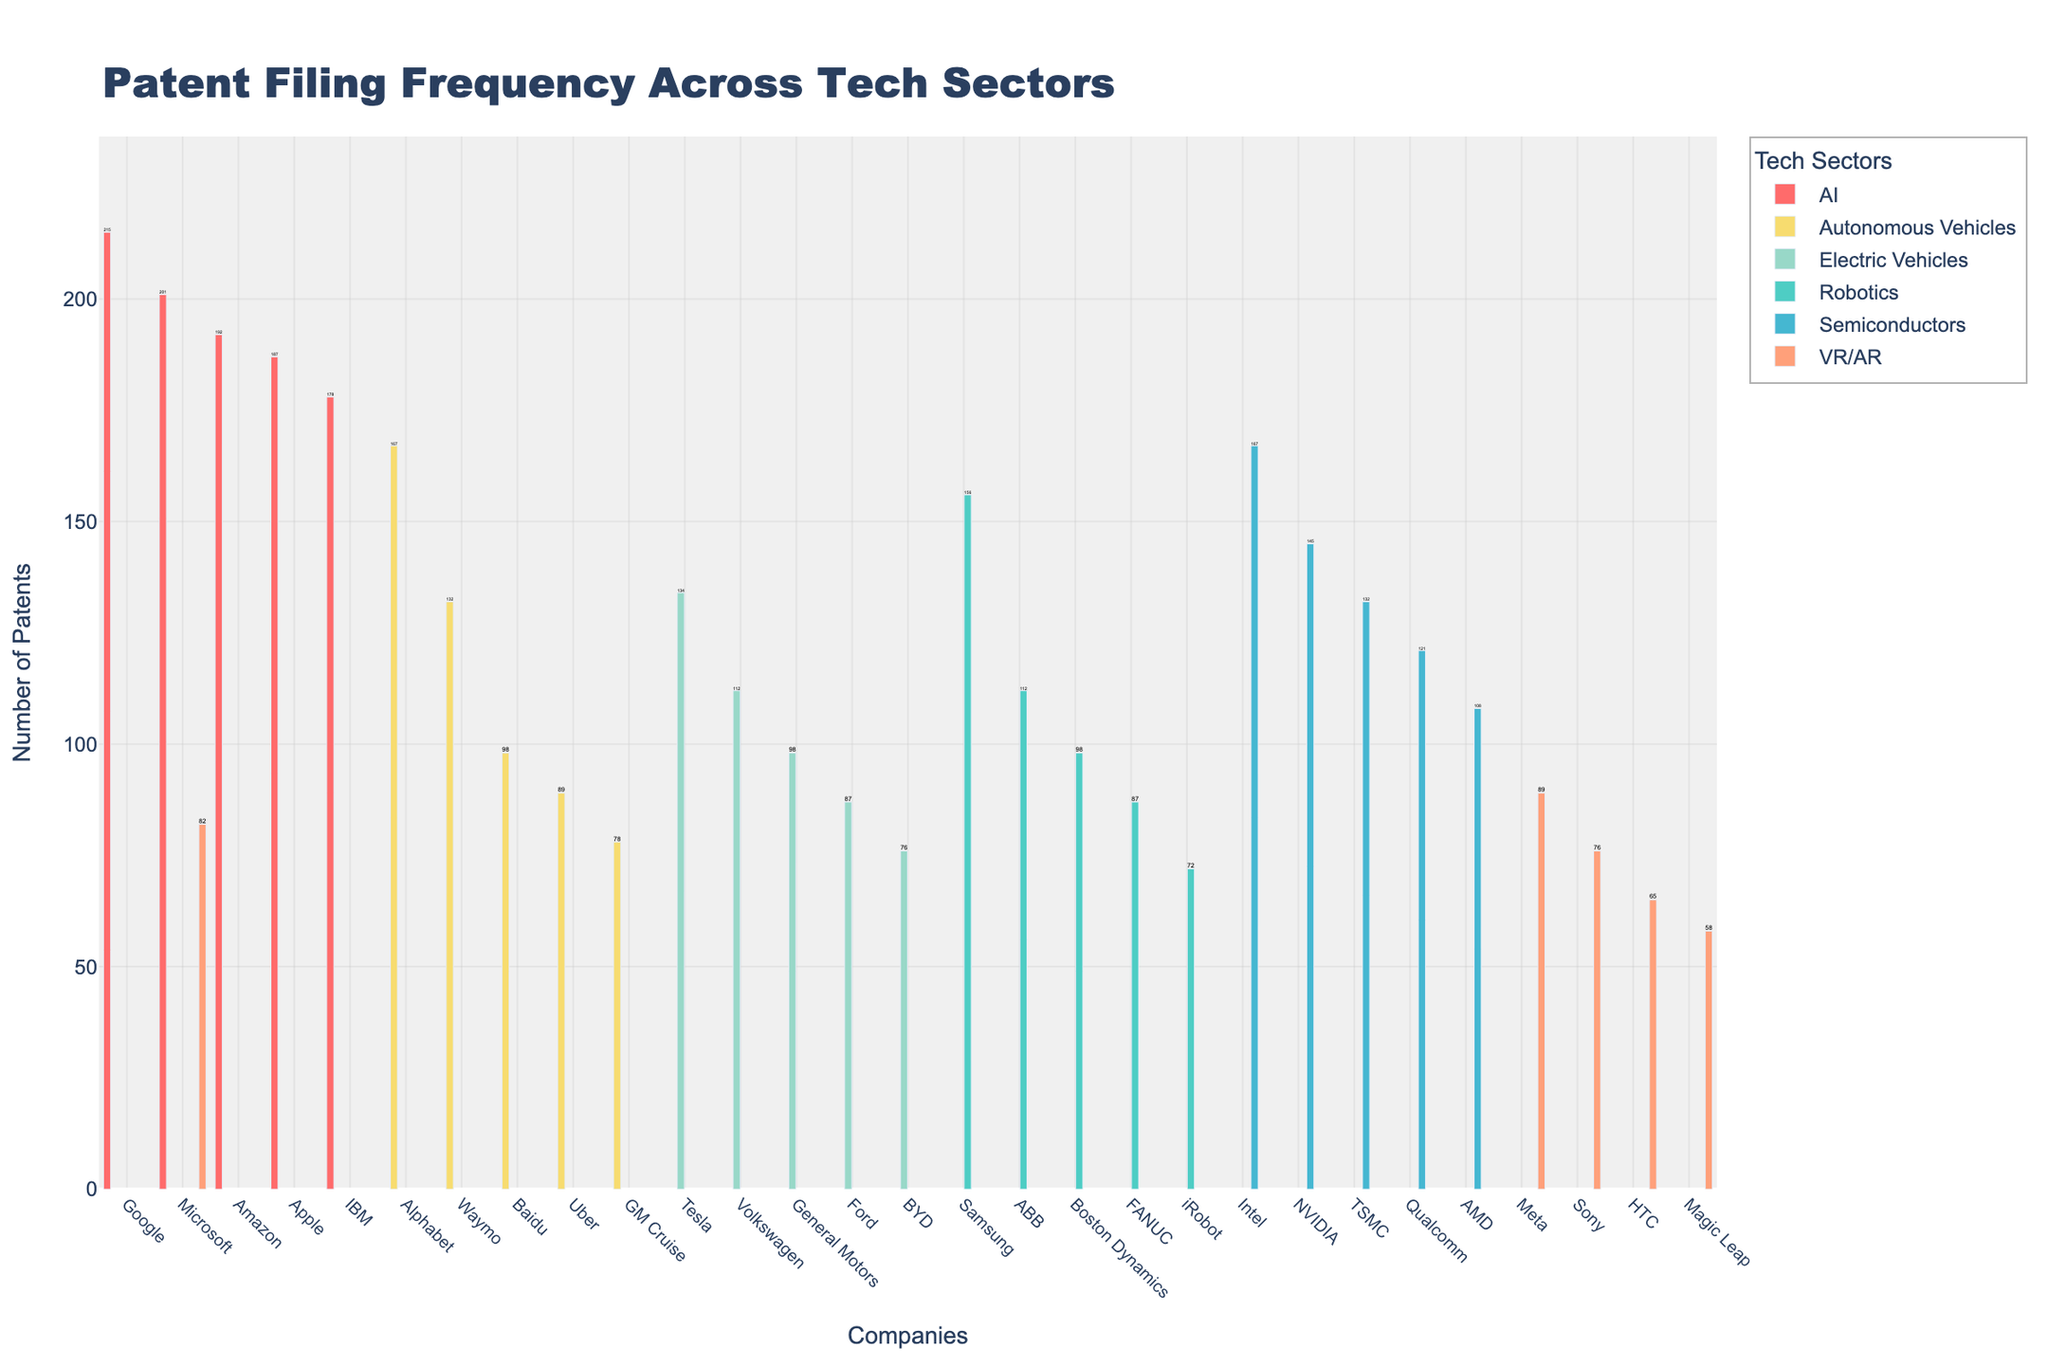What is the total number of patents filed by AI companies? Add the patent counts of companies in the AI sector: Apple (187), Google (215), Microsoft (201), IBM (178), Amazon (192). Their sum is 187 + 215 + 201 + 178 + 192 = 973.
Answer: 973 Which sector has the highest number of patents filed by a single company? Identify the highest patent count filed by a single company across all sectors. Google in the AI sector has the highest with 215 patents.
Answer: AI How many companies in the Electric Vehicles sector have filed patents? Count the number of companies in the Electric Vehicles sector listed in the chart: Tesla, General Motors, Ford, Volkswagen, and BYD. There are 5 companies.
Answer: 5 Which company in the Robotics sector has the least number of patents filed? Identify the company with the lowest patent count in the Robotics sector. iRobot has the least with 72 patents.
Answer: iRobot Compare the patent counts of NVIDIA and Intel in the Semiconductors sector. Which one is higher, and by how much? NVIDIA has 145 patents and Intel has 167 patents. Intel has 167 - 145 = 22 more patents than NVIDIA.
Answer: Intel by 22 How many sectors have at least one company with more than 150 patents filed? Count the sectors where at least one company has more than 150 patents. Sectors fitting this are AI (Google, Microsoft), Semiconductors (Intel), Electric Vehicles (none), Autonomous Vehicles (Alphabet). There are 3 sectors.
Answer: 3 What is the average number of patents filed per company in the VR/AR sector? Calculate the average by summing the patents in VR/AR and dividing by the number of companies: Meta (89), Sony (76), HTC (65), Magic Leap (58), Microsoft (82). Sum is 89 + 76 + 65 + 58 + 82 = 370. Average is 370 / 5 = 74.
Answer: 74 Among the companies listed in the Autonomous Vehicles sector, which one has filed the second most patents? List the patent counts in Autonomous Vehicles: Alphabet (167), Waymo (132), Baidu (98), Uber (89), GM Cruise (78). Waymo with 132 patents is the second highest.
Answer: Waymo What is the total number of patents filed by companies in the Robotics sector? Add the patent counts of companies in the Robotics sector: Samsung (156), Boston Dynamics (98), ABB (112), FANUC (87), iRobot (72). Their sum is 156 + 98 + 112 + 87 + 72 = 525.
Answer: 525 Which tech company has filed the lowest overall number of patents in the chart? Identify the lowest patent count in the entire chart. Magic Leap in the VR/AR sector has the lowest with 58 patents.
Answer: Magic Leap 